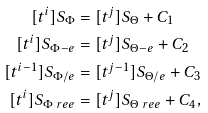<formula> <loc_0><loc_0><loc_500><loc_500>[ t ^ { i } ] S _ { \Phi } & = [ t ^ { j } ] S _ { \Theta } + C _ { 1 } \\ [ t ^ { i } ] S _ { \Phi - e } & = [ t ^ { j } ] S _ { \Theta - e } + C _ { 2 } \\ [ t ^ { i - 1 } ] S _ { \Phi / e } & = [ t ^ { j - 1 } ] S _ { \Theta / e } + C _ { 3 } \\ [ t ^ { i } ] S _ { \Phi \ r e e } & = [ t ^ { j } ] S _ { \Theta \ r e e } + C _ { 4 } ,</formula> 